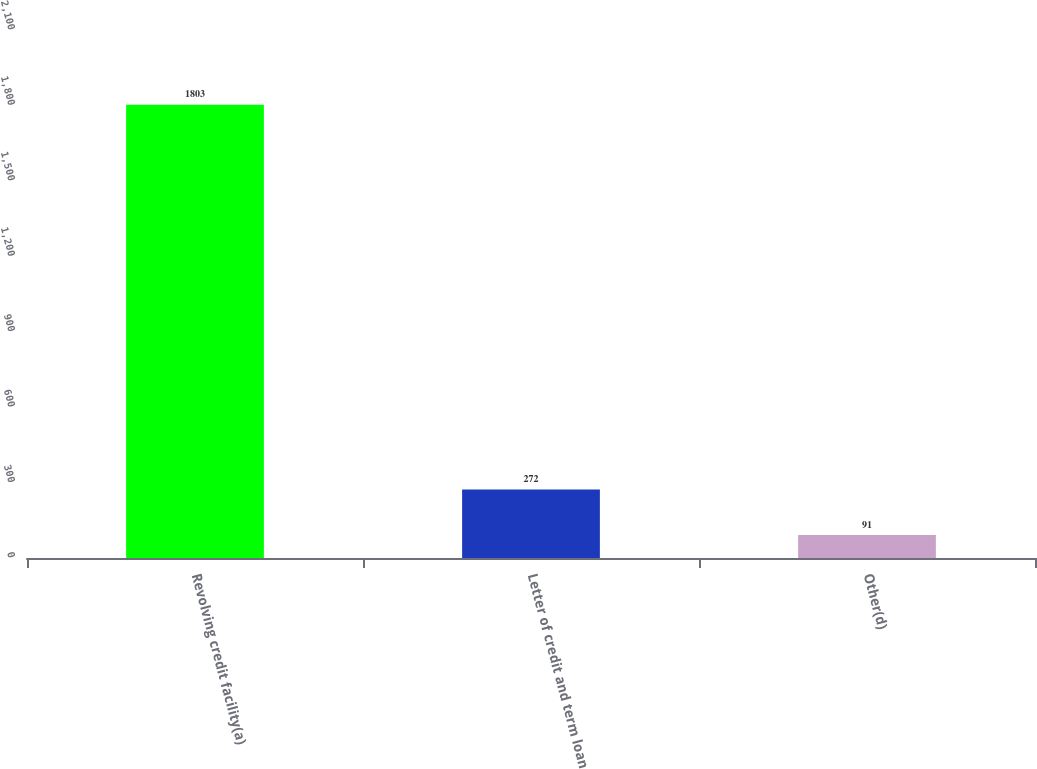<chart> <loc_0><loc_0><loc_500><loc_500><bar_chart><fcel>Revolving credit facility(a)<fcel>Letter of credit and term loan<fcel>Other(d)<nl><fcel>1803<fcel>272<fcel>91<nl></chart> 